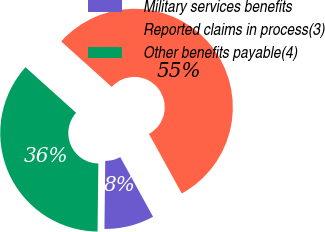Convert chart. <chart><loc_0><loc_0><loc_500><loc_500><pie_chart><fcel>Military services benefits<fcel>Reported claims in process(3)<fcel>Other benefits payable(4)<nl><fcel>8.19%<fcel>55.33%<fcel>36.48%<nl></chart> 